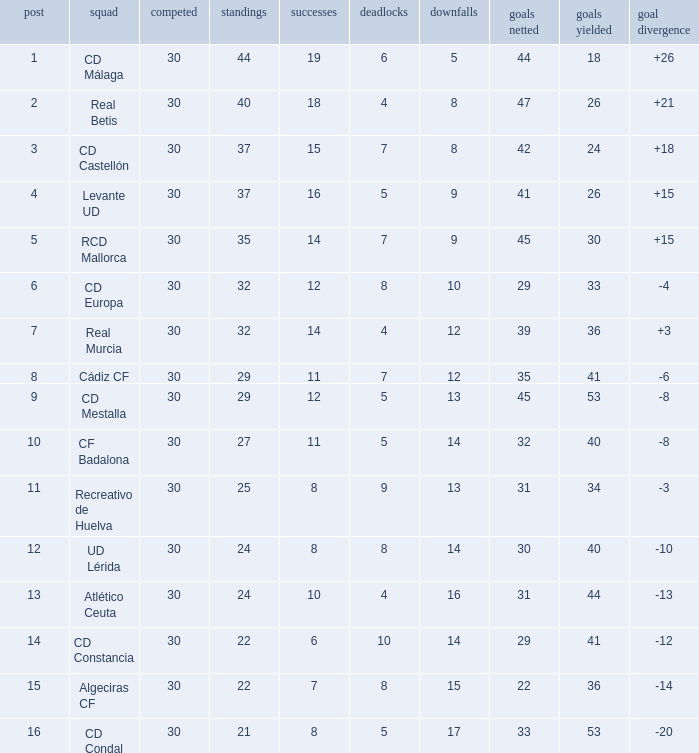What is the losses when the goal difference is larger than 26? None. 